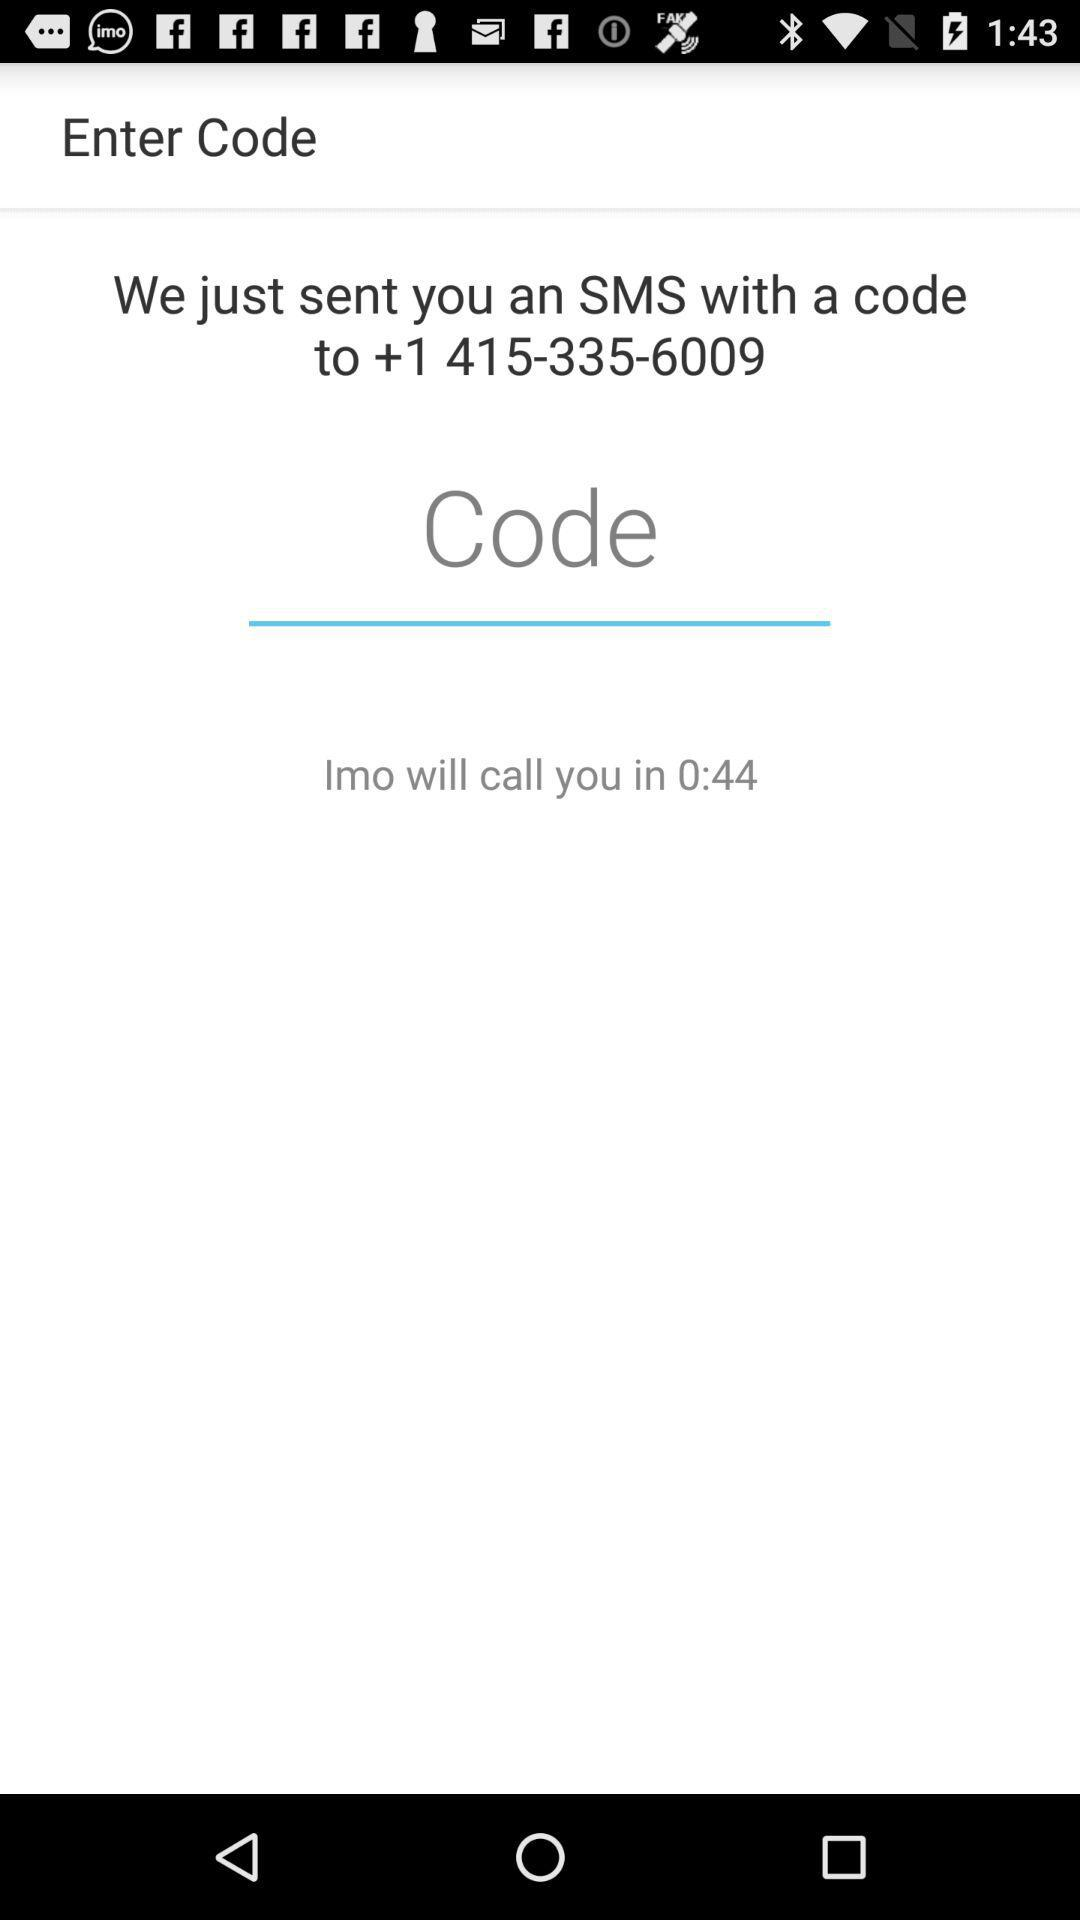What number is used for verification? The number is +1 415-335-6009. 